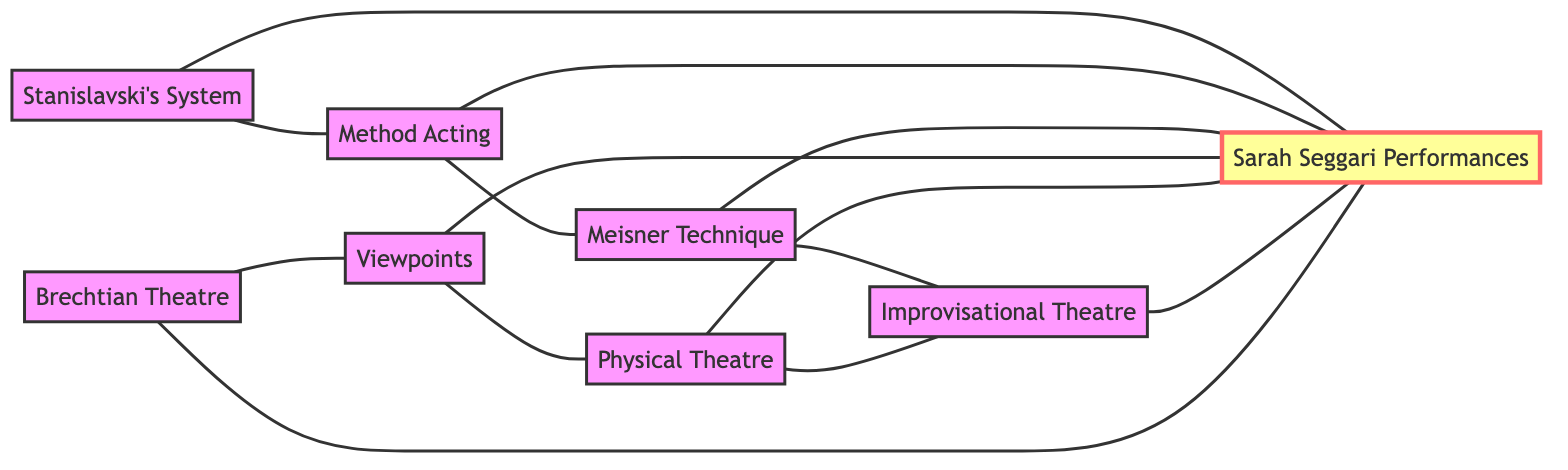What are the main techniques connected to Sarah Seggari's performances? The diagram shows multiple techniques directly connecting to the node "Sarah Seggari Performances," which are Stanislavski's System, Method Acting, Meisner Technique, Viewpoints, Physical Theatre, Improvisational Theatre, and Brechtian Theatre.
Answer: Stanislavski's System, Method Acting, Meisner Technique, Viewpoints, Physical Theatre, Improvisational Theatre, Brechtian Theatre How many total nodes are there in this diagram? By counting the distinct techniques and performances represented in the diagram, there are 8 nodes: 7 theatre techniques and 1 Sarah Seggari Performances node.
Answer: 8 Which techniques are connected to both Improvisational Theatre and Sarah Seggari's performances? Looking at the edges connected to the Improvisational Theatre node, it connects back to Meisner Technique and Physical Theatre, and it also connects directly to the Sarah Seggari Performances node. Thus, the two techniques connected to both are Meisner Technique and Physical Theatre.
Answer: Meisner Technique, Physical Theatre Which technique has the most connections in the diagram? Evaluating each node's connections shows that "Sarah Seggari Performances" connects to 6 other techniques, while other techniques generally have fewer connections. Hence, "Sarah Seggari Performances" has the most connections.
Answer: Sarah Seggari Performances Is there a direct connection between Brechtian Theatre and Method Acting? The diagram does not show a direct edge between the nodes "Brechtian Theatre" and "Method Acting," indicating they are not directly connected. Review of the edges confirms only indirect connections.
Answer: No 